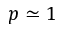Convert formula to latex. <formula><loc_0><loc_0><loc_500><loc_500>p \simeq 1</formula> 